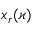Convert formula to latex. <formula><loc_0><loc_0><loc_500><loc_500>x _ { r } ( \varkappa )</formula> 